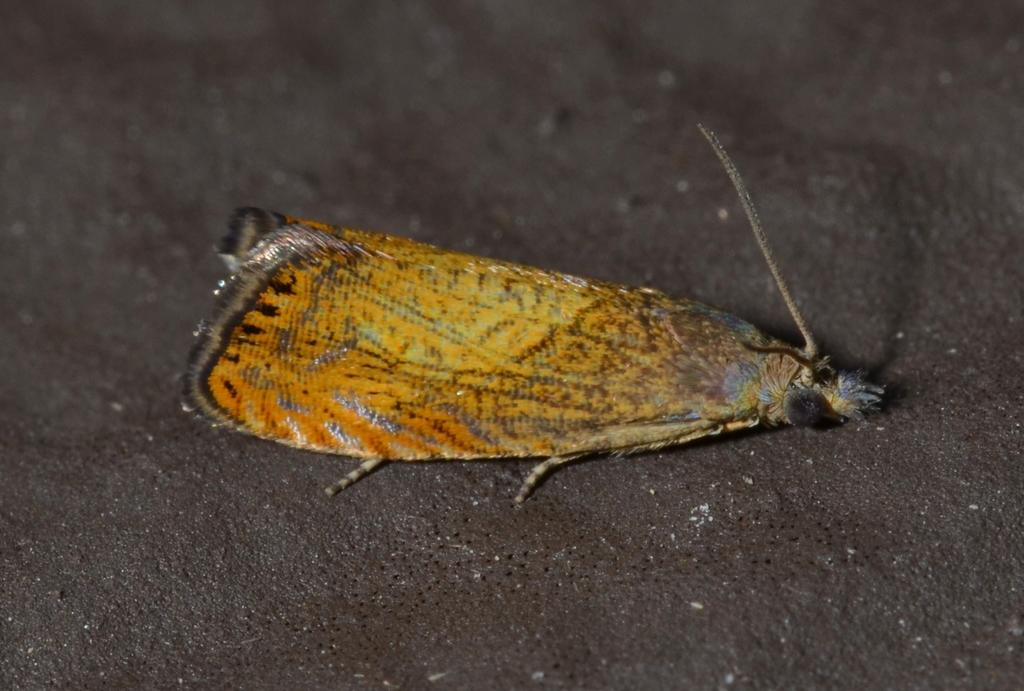What is located in the foreground of the image? There is a fly in the foreground of the image. Can you describe the lighting conditions in the image? The image may have been taken during the night, as it appears to be dark. Reasoning: Let' Let's think step by step in order to produce the conversation. We start by identifying the main subject in the foreground, which is the fly. Then, we focus on the lighting conditions in the image, which are described as potentially being during the night due to the darkness. We avoid making assumptions about the image and stick to the facts provided. Absurd Question/Answer: What idea does the fly have about crossing the stream in the image? There is no stream present in the image, and the fly's thoughts or ideas cannot be determined. 